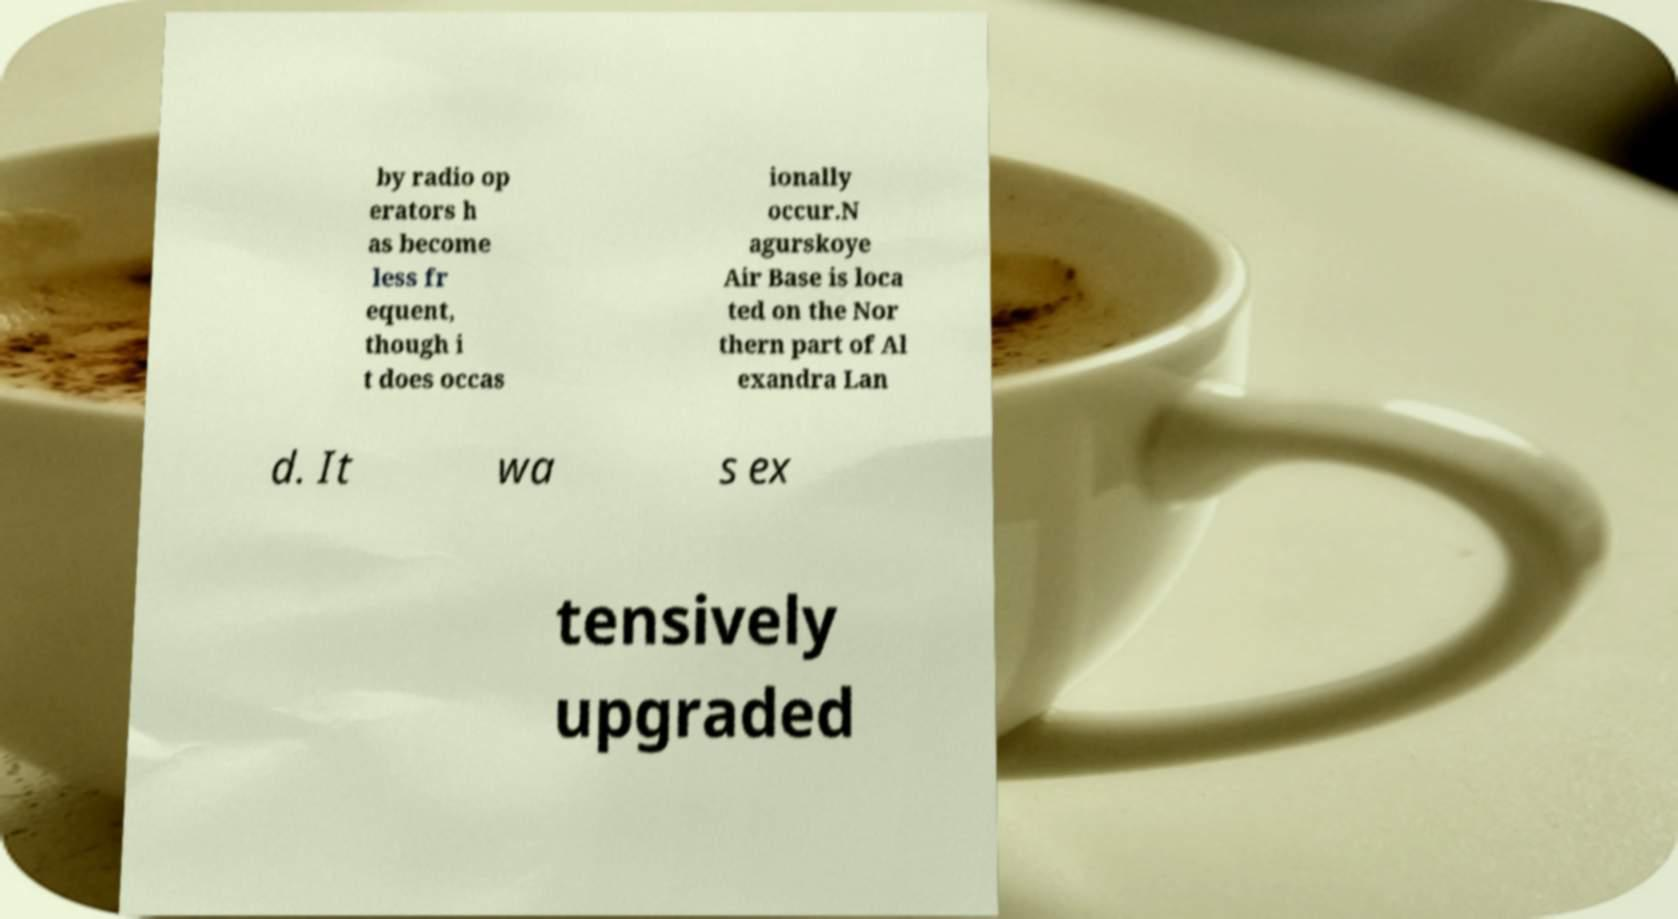What messages or text are displayed in this image? I need them in a readable, typed format. by radio op erators h as become less fr equent, though i t does occas ionally occur.N agurskoye Air Base is loca ted on the Nor thern part of Al exandra Lan d. It wa s ex tensively upgraded 